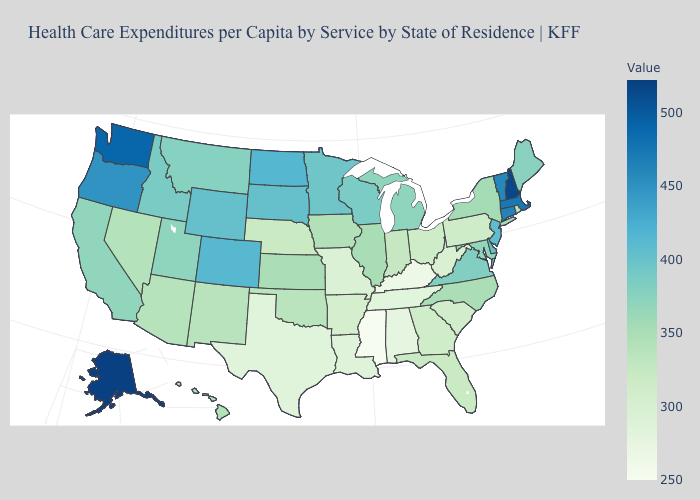Does Ohio have a higher value than Louisiana?
Answer briefly. Yes. Which states have the lowest value in the USA?
Keep it brief. Mississippi. Among the states that border New Hampshire , which have the lowest value?
Give a very brief answer. Maine. Among the states that border Nebraska , which have the lowest value?
Short answer required. Missouri. Which states hav the highest value in the Northeast?
Give a very brief answer. New Hampshire. 